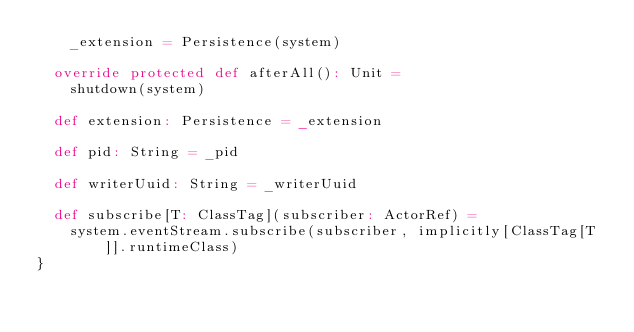<code> <loc_0><loc_0><loc_500><loc_500><_Scala_>    _extension = Persistence(system)

  override protected def afterAll(): Unit =
    shutdown(system)

  def extension: Persistence = _extension

  def pid: String = _pid

  def writerUuid: String = _writerUuid

  def subscribe[T: ClassTag](subscriber: ActorRef) =
    system.eventStream.subscribe(subscriber, implicitly[ClassTag[T]].runtimeClass)
}
</code> 